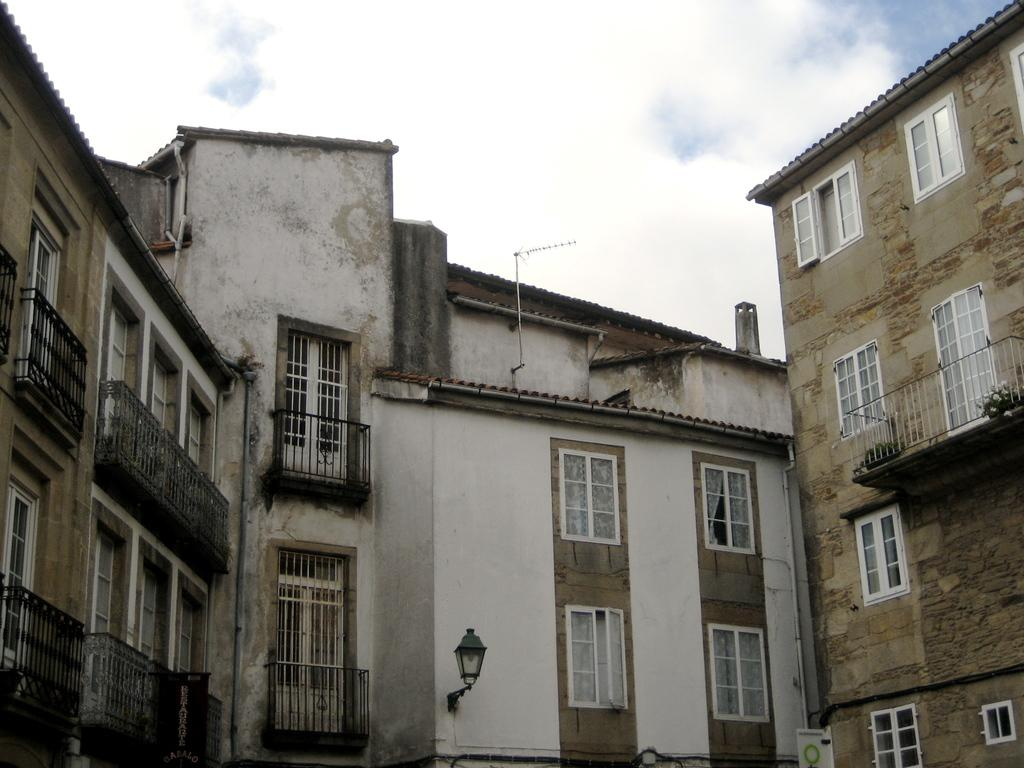What type of structures are present in the image? There are buildings in the image. What feature can be seen on the balconies of the buildings? The buildings have metal rod balconies. What sign is visible in the image? There is a name board in the image. What type of lighting is present in the image? There is a lamp in the image. What type of communication device is visible in the image? There is an antenna in the image. What additional signage is present in the image? There is a banner in the image. What can be seen in the sky in the image? The sky is visible at the top of the image, and there are clouds in the sky. How many accounts are mentioned on the banner in the image? There are no accounts mentioned on the banner in the image. What type of bomb is visible in the image? There is no bomb present in the image. 